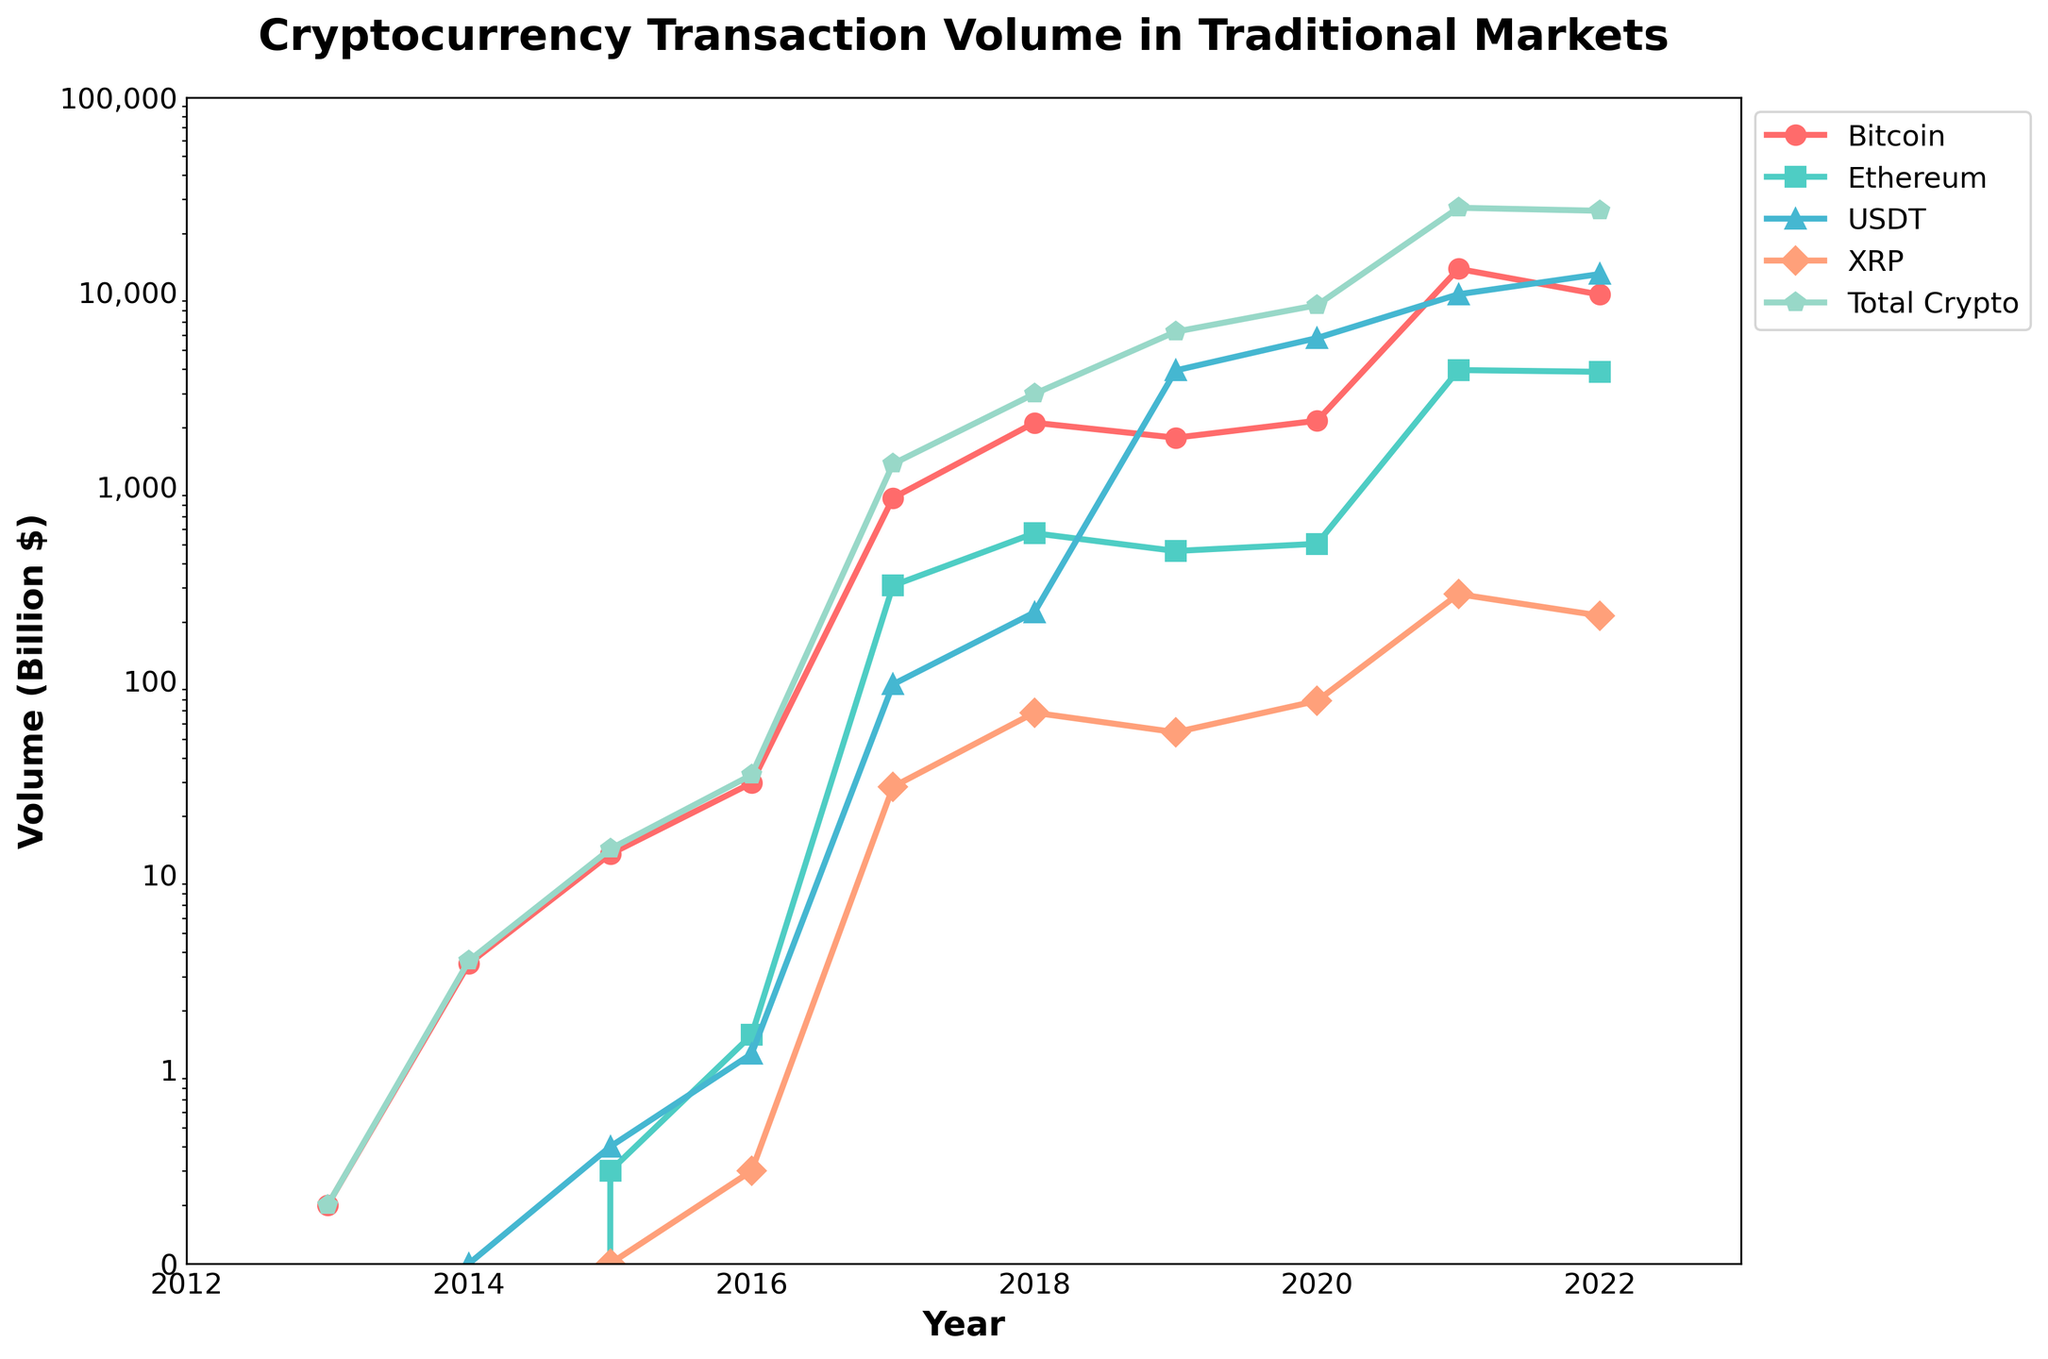What is the total volume of Bitcoin transactions in 2017? To find the total volume of Bitcoin transactions in 2017, locate the year 2017 on the x-axis and then refer to the data point for the Bitcoin line. The Bitcoin transaction volume for 2017 is 870.5 billion dollars.
Answer: 870.5 billion dollars Which cryptocurrency had the highest transaction volume in 2021? To determine which cryptocurrency had the highest transaction volume in 2021, locate the year 2021 on the x-axis and compare the heights of the data points for each cryptocurrency. The USDT line reaches the highest point in 2021, indicating the highest transaction volume.
Answer: USDT By how much did the total cryptocurrency transaction volume increase from 2016 to 2017? To find the increase in total cryptocurrency transaction volume from 2016 to 2017, subtract the total volume of 2016 (32.7 billion dollars) from the total volume of 2017 (1302.7 billion dollars). The increase is 1302.7 - 32.7 = 1270 billion dollars.
Answer: 1270 billion dollars What is the average volume of XRP transactions from 2018 to 2020? Calculate the average volume of XRP transactions from 2018 to 2020 by adding the volumes for each year and dividing by the number of years. The volumes are 68.3, 54.2, and 78.6 billion dollars. The sum is 68.3 + 54.2 + 78.6 = 201.1 billion dollars. Divide by 3 to get 201.1 / 3 ≈ 67 billion dollars.
Answer: 67 billion dollars Which year had the largest growth in the total cryptocurrency transaction volume? To identify the year with the largest growth, examine the vertical distance (increase) between consecutive data points on the Total Crypto Volume line. The largest increase occurs between 2020 and 2021, where the volume jumps from 8538.9 billion dollars to 27075.7 billion dollars.
Answer: 2021 Compare the transaction volume of Bitcoin in 2019 with Ethereum in 2020. Which is higher and by how much? To compare the volumes, look at Bitcoin’s volume in 2019 (1775.6 billion dollars) and Ethereum’s volume in 2020 (505.3 billion dollars). Bitcoin's volume is higher. The difference is 1775.6 - 505.3 = 1270.3 billion dollars.
Answer: Bitcoin by 1270.3 billion dollars What is the proportion of USDT's volume to the total crypto volume in 2022? To find the proportion, divide USDT’s volume in 2022 by the total crypto volume of the same year. USDT's volume is 12345.8 billion dollars, and the total is 26117.4 billion dollars. The proportion is 12345.8 / 26117.4 ≈ 0.472, or 47.2%.
Answer: 47.2% How did the total cryptocurrency transaction volume change from 2014 to 2015? Identify the total volumes for 2014 (3.62 billion dollars) and 2015 (13.6 billion dollars). Subtract 2014’s volume from 2015’s volume: 13.6 - 3.62 = 9.98 billion dollars increase.
Answer: Increase of 9.98 billion dollars What are the differences in Bitcoin transaction volumes between 2014 and 2015? Find the Bitcoin transaction volumes for 2014 (3.5 billion dollars) and 2015 (12.8 billion dollars). Subtract the 2014 volume from the 2015 volume: 12.8 - 3.5 = 9.3 billion dollars.
Answer: 9.3 billion dollars 